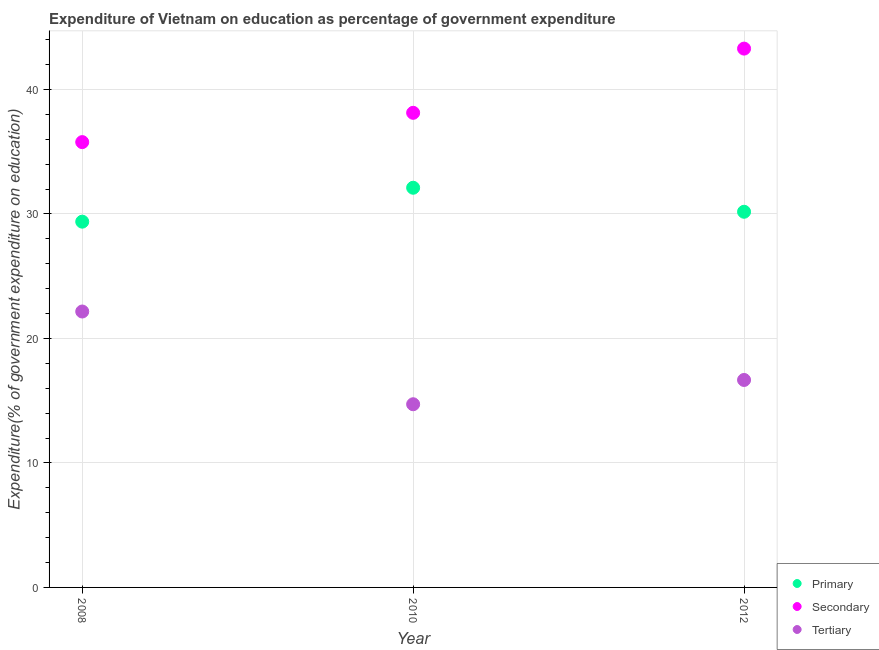How many different coloured dotlines are there?
Offer a very short reply. 3. Is the number of dotlines equal to the number of legend labels?
Ensure brevity in your answer.  Yes. What is the expenditure on tertiary education in 2008?
Your response must be concise. 22.16. Across all years, what is the maximum expenditure on tertiary education?
Offer a terse response. 22.16. Across all years, what is the minimum expenditure on tertiary education?
Keep it short and to the point. 14.72. In which year was the expenditure on secondary education maximum?
Offer a very short reply. 2012. What is the total expenditure on primary education in the graph?
Keep it short and to the point. 91.67. What is the difference between the expenditure on secondary education in 2010 and that in 2012?
Provide a short and direct response. -5.16. What is the difference between the expenditure on tertiary education in 2010 and the expenditure on primary education in 2012?
Give a very brief answer. -15.46. What is the average expenditure on primary education per year?
Keep it short and to the point. 30.56. In the year 2008, what is the difference between the expenditure on tertiary education and expenditure on secondary education?
Offer a terse response. -13.61. What is the ratio of the expenditure on tertiary education in 2010 to that in 2012?
Ensure brevity in your answer.  0.88. Is the difference between the expenditure on secondary education in 2010 and 2012 greater than the difference between the expenditure on tertiary education in 2010 and 2012?
Provide a succinct answer. No. What is the difference between the highest and the second highest expenditure on primary education?
Your response must be concise. 1.93. What is the difference between the highest and the lowest expenditure on primary education?
Offer a very short reply. 2.72. Is it the case that in every year, the sum of the expenditure on primary education and expenditure on secondary education is greater than the expenditure on tertiary education?
Make the answer very short. Yes. How many dotlines are there?
Your answer should be compact. 3. What is the difference between two consecutive major ticks on the Y-axis?
Make the answer very short. 10. Where does the legend appear in the graph?
Your answer should be compact. Bottom right. How many legend labels are there?
Your response must be concise. 3. What is the title of the graph?
Provide a succinct answer. Expenditure of Vietnam on education as percentage of government expenditure. What is the label or title of the Y-axis?
Your response must be concise. Expenditure(% of government expenditure on education). What is the Expenditure(% of government expenditure on education) of Primary in 2008?
Keep it short and to the point. 29.38. What is the Expenditure(% of government expenditure on education) in Secondary in 2008?
Your answer should be very brief. 35.77. What is the Expenditure(% of government expenditure on education) of Tertiary in 2008?
Your answer should be very brief. 22.16. What is the Expenditure(% of government expenditure on education) of Primary in 2010?
Give a very brief answer. 32.11. What is the Expenditure(% of government expenditure on education) in Secondary in 2010?
Offer a very short reply. 38.13. What is the Expenditure(% of government expenditure on education) of Tertiary in 2010?
Your answer should be compact. 14.72. What is the Expenditure(% of government expenditure on education) in Primary in 2012?
Keep it short and to the point. 30.18. What is the Expenditure(% of government expenditure on education) of Secondary in 2012?
Offer a very short reply. 43.28. What is the Expenditure(% of government expenditure on education) of Tertiary in 2012?
Make the answer very short. 16.67. Across all years, what is the maximum Expenditure(% of government expenditure on education) of Primary?
Give a very brief answer. 32.11. Across all years, what is the maximum Expenditure(% of government expenditure on education) of Secondary?
Your answer should be very brief. 43.28. Across all years, what is the maximum Expenditure(% of government expenditure on education) in Tertiary?
Your answer should be compact. 22.16. Across all years, what is the minimum Expenditure(% of government expenditure on education) in Primary?
Offer a very short reply. 29.38. Across all years, what is the minimum Expenditure(% of government expenditure on education) of Secondary?
Make the answer very short. 35.77. Across all years, what is the minimum Expenditure(% of government expenditure on education) in Tertiary?
Your answer should be compact. 14.72. What is the total Expenditure(% of government expenditure on education) in Primary in the graph?
Your response must be concise. 91.67. What is the total Expenditure(% of government expenditure on education) in Secondary in the graph?
Offer a terse response. 117.18. What is the total Expenditure(% of government expenditure on education) of Tertiary in the graph?
Provide a succinct answer. 53.55. What is the difference between the Expenditure(% of government expenditure on education) in Primary in 2008 and that in 2010?
Your answer should be compact. -2.72. What is the difference between the Expenditure(% of government expenditure on education) of Secondary in 2008 and that in 2010?
Ensure brevity in your answer.  -2.35. What is the difference between the Expenditure(% of government expenditure on education) of Tertiary in 2008 and that in 2010?
Your response must be concise. 7.45. What is the difference between the Expenditure(% of government expenditure on education) of Primary in 2008 and that in 2012?
Ensure brevity in your answer.  -0.79. What is the difference between the Expenditure(% of government expenditure on education) in Secondary in 2008 and that in 2012?
Your response must be concise. -7.51. What is the difference between the Expenditure(% of government expenditure on education) of Tertiary in 2008 and that in 2012?
Keep it short and to the point. 5.5. What is the difference between the Expenditure(% of government expenditure on education) of Primary in 2010 and that in 2012?
Provide a short and direct response. 1.93. What is the difference between the Expenditure(% of government expenditure on education) of Secondary in 2010 and that in 2012?
Your response must be concise. -5.16. What is the difference between the Expenditure(% of government expenditure on education) in Tertiary in 2010 and that in 2012?
Your response must be concise. -1.95. What is the difference between the Expenditure(% of government expenditure on education) in Primary in 2008 and the Expenditure(% of government expenditure on education) in Secondary in 2010?
Ensure brevity in your answer.  -8.74. What is the difference between the Expenditure(% of government expenditure on education) in Primary in 2008 and the Expenditure(% of government expenditure on education) in Tertiary in 2010?
Offer a very short reply. 14.67. What is the difference between the Expenditure(% of government expenditure on education) of Secondary in 2008 and the Expenditure(% of government expenditure on education) of Tertiary in 2010?
Make the answer very short. 21.06. What is the difference between the Expenditure(% of government expenditure on education) in Primary in 2008 and the Expenditure(% of government expenditure on education) in Secondary in 2012?
Your answer should be compact. -13.9. What is the difference between the Expenditure(% of government expenditure on education) in Primary in 2008 and the Expenditure(% of government expenditure on education) in Tertiary in 2012?
Keep it short and to the point. 12.72. What is the difference between the Expenditure(% of government expenditure on education) in Secondary in 2008 and the Expenditure(% of government expenditure on education) in Tertiary in 2012?
Provide a succinct answer. 19.11. What is the difference between the Expenditure(% of government expenditure on education) in Primary in 2010 and the Expenditure(% of government expenditure on education) in Secondary in 2012?
Your answer should be compact. -11.18. What is the difference between the Expenditure(% of government expenditure on education) of Primary in 2010 and the Expenditure(% of government expenditure on education) of Tertiary in 2012?
Keep it short and to the point. 15.44. What is the difference between the Expenditure(% of government expenditure on education) of Secondary in 2010 and the Expenditure(% of government expenditure on education) of Tertiary in 2012?
Make the answer very short. 21.46. What is the average Expenditure(% of government expenditure on education) of Primary per year?
Ensure brevity in your answer.  30.56. What is the average Expenditure(% of government expenditure on education) of Secondary per year?
Keep it short and to the point. 39.06. What is the average Expenditure(% of government expenditure on education) of Tertiary per year?
Your answer should be very brief. 17.85. In the year 2008, what is the difference between the Expenditure(% of government expenditure on education) of Primary and Expenditure(% of government expenditure on education) of Secondary?
Offer a terse response. -6.39. In the year 2008, what is the difference between the Expenditure(% of government expenditure on education) of Primary and Expenditure(% of government expenditure on education) of Tertiary?
Give a very brief answer. 7.22. In the year 2008, what is the difference between the Expenditure(% of government expenditure on education) in Secondary and Expenditure(% of government expenditure on education) in Tertiary?
Offer a terse response. 13.61. In the year 2010, what is the difference between the Expenditure(% of government expenditure on education) in Primary and Expenditure(% of government expenditure on education) in Secondary?
Keep it short and to the point. -6.02. In the year 2010, what is the difference between the Expenditure(% of government expenditure on education) of Primary and Expenditure(% of government expenditure on education) of Tertiary?
Keep it short and to the point. 17.39. In the year 2010, what is the difference between the Expenditure(% of government expenditure on education) in Secondary and Expenditure(% of government expenditure on education) in Tertiary?
Give a very brief answer. 23.41. In the year 2012, what is the difference between the Expenditure(% of government expenditure on education) in Primary and Expenditure(% of government expenditure on education) in Secondary?
Keep it short and to the point. -13.11. In the year 2012, what is the difference between the Expenditure(% of government expenditure on education) of Primary and Expenditure(% of government expenditure on education) of Tertiary?
Provide a succinct answer. 13.51. In the year 2012, what is the difference between the Expenditure(% of government expenditure on education) in Secondary and Expenditure(% of government expenditure on education) in Tertiary?
Keep it short and to the point. 26.62. What is the ratio of the Expenditure(% of government expenditure on education) in Primary in 2008 to that in 2010?
Provide a succinct answer. 0.92. What is the ratio of the Expenditure(% of government expenditure on education) in Secondary in 2008 to that in 2010?
Give a very brief answer. 0.94. What is the ratio of the Expenditure(% of government expenditure on education) of Tertiary in 2008 to that in 2010?
Offer a very short reply. 1.51. What is the ratio of the Expenditure(% of government expenditure on education) in Primary in 2008 to that in 2012?
Your answer should be very brief. 0.97. What is the ratio of the Expenditure(% of government expenditure on education) in Secondary in 2008 to that in 2012?
Offer a terse response. 0.83. What is the ratio of the Expenditure(% of government expenditure on education) of Tertiary in 2008 to that in 2012?
Your response must be concise. 1.33. What is the ratio of the Expenditure(% of government expenditure on education) in Primary in 2010 to that in 2012?
Make the answer very short. 1.06. What is the ratio of the Expenditure(% of government expenditure on education) of Secondary in 2010 to that in 2012?
Your answer should be very brief. 0.88. What is the ratio of the Expenditure(% of government expenditure on education) in Tertiary in 2010 to that in 2012?
Offer a terse response. 0.88. What is the difference between the highest and the second highest Expenditure(% of government expenditure on education) of Primary?
Offer a very short reply. 1.93. What is the difference between the highest and the second highest Expenditure(% of government expenditure on education) in Secondary?
Your response must be concise. 5.16. What is the difference between the highest and the second highest Expenditure(% of government expenditure on education) of Tertiary?
Make the answer very short. 5.5. What is the difference between the highest and the lowest Expenditure(% of government expenditure on education) in Primary?
Keep it short and to the point. 2.72. What is the difference between the highest and the lowest Expenditure(% of government expenditure on education) of Secondary?
Keep it short and to the point. 7.51. What is the difference between the highest and the lowest Expenditure(% of government expenditure on education) in Tertiary?
Ensure brevity in your answer.  7.45. 